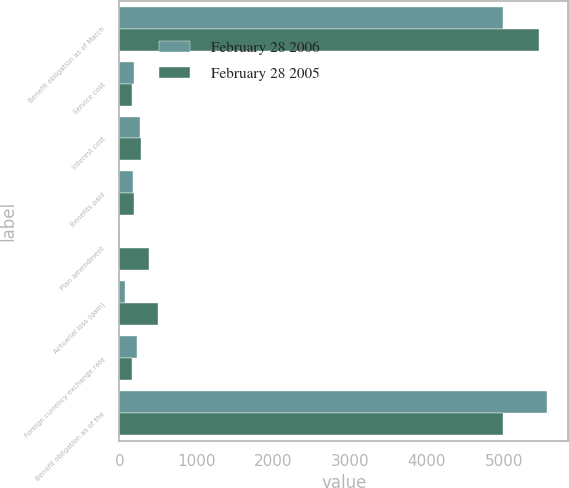<chart> <loc_0><loc_0><loc_500><loc_500><stacked_bar_chart><ecel><fcel>Benefit obligation as of March<fcel>Service cost<fcel>Interest cost<fcel>Benefits paid<fcel>Plan amendment<fcel>Actuarial loss (gain)<fcel>Foreign currency exchange rate<fcel>Benefit obligation as of the<nl><fcel>February 28 2006<fcel>4989<fcel>186<fcel>264<fcel>174<fcel>8<fcel>72<fcel>231<fcel>5560<nl><fcel>February 28 2005<fcel>5460<fcel>158<fcel>275<fcel>186<fcel>383<fcel>499<fcel>164<fcel>4989<nl></chart> 